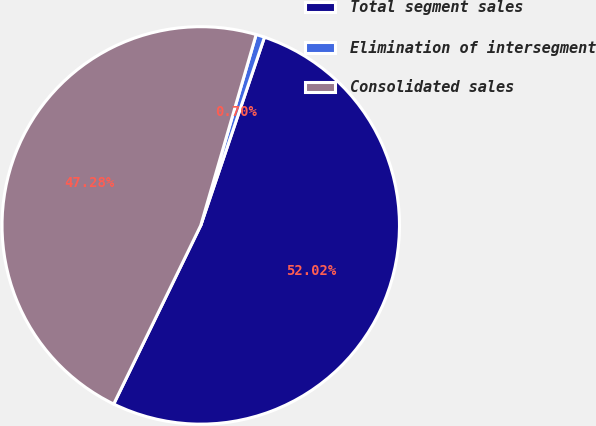Convert chart. <chart><loc_0><loc_0><loc_500><loc_500><pie_chart><fcel>Total segment sales<fcel>Elimination of intersegment<fcel>Consolidated sales<nl><fcel>52.02%<fcel>0.7%<fcel>47.28%<nl></chart> 